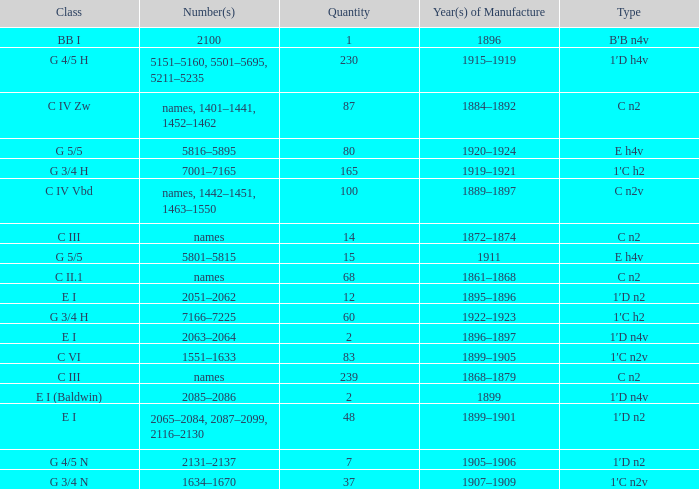Which Class has a Year(s) of Manufacture of 1899? E I (Baldwin). 